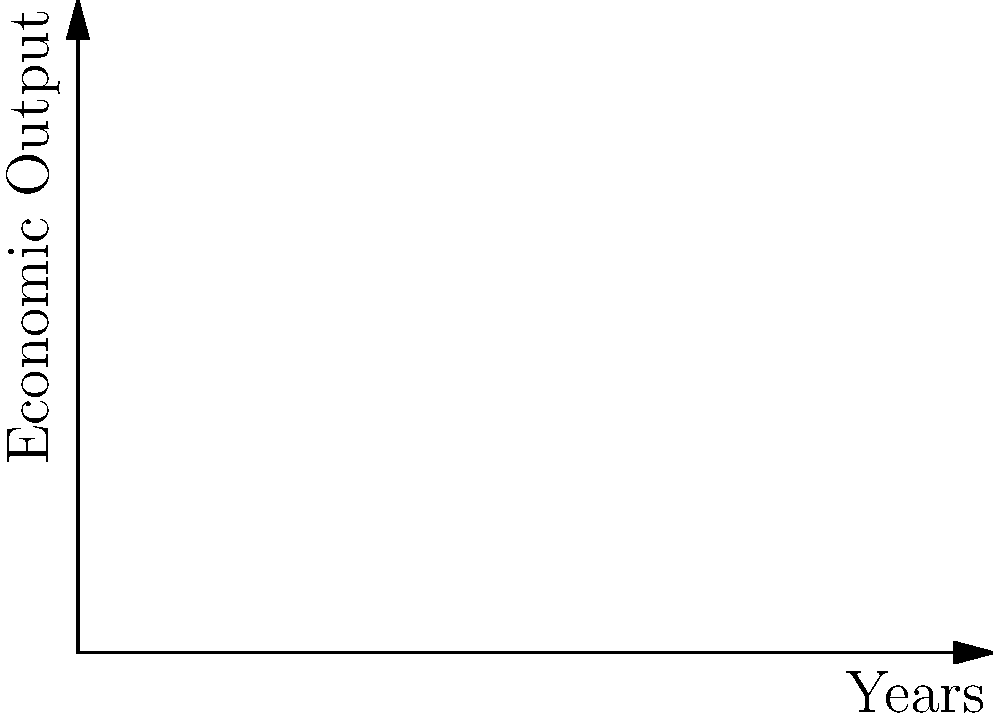The graph shows the economic output of three empires over time, represented by polynomial functions. Which empire exhibits the highest rate of economic growth in the later years, and what historical factors might explain this trend? To determine which empire has the highest rate of economic growth in later years, we need to analyze the slopes of the curves towards the right side of the graph:

1. Empire A (blue curve): $f(x) = 0.1x^3 - 0.5x^2 + 2x + 10$
2. Empire B (red curve): $g(x) = 0.05x^3 + 0.2x^2 + x + 5$
3. Empire C (green curve): $h(x) = 0.02x^3 + x^2 - x + 8$

The rate of growth is represented by the first derivative of each function:

1. $f'(x) = 0.3x^2 - x + 2$
2. $g'(x) = 0.15x^2 + 0.4x + 1$
3. $h'(x) = 0.06x^2 + 2x - 1$

As x increases (later years), the term with the highest degree dominates. Empire A has the highest coefficient for $x^2$ (0.3), indicating the steepest growth in later years.

Historical factors that might explain this trend:
1. Technological advancements
2. Efficient resource management
3. Expansionist policies
4. Trade route dominance
5. Agricultural or industrial revolutions

These factors could lead to exponential growth, as represented by the cubic function with the highest coefficient.
Answer: Empire A shows the highest growth rate in later years, possibly due to technological advancements, efficient resource management, or successful expansionist policies. 